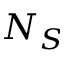Convert formula to latex. <formula><loc_0><loc_0><loc_500><loc_500>N _ { S }</formula> 